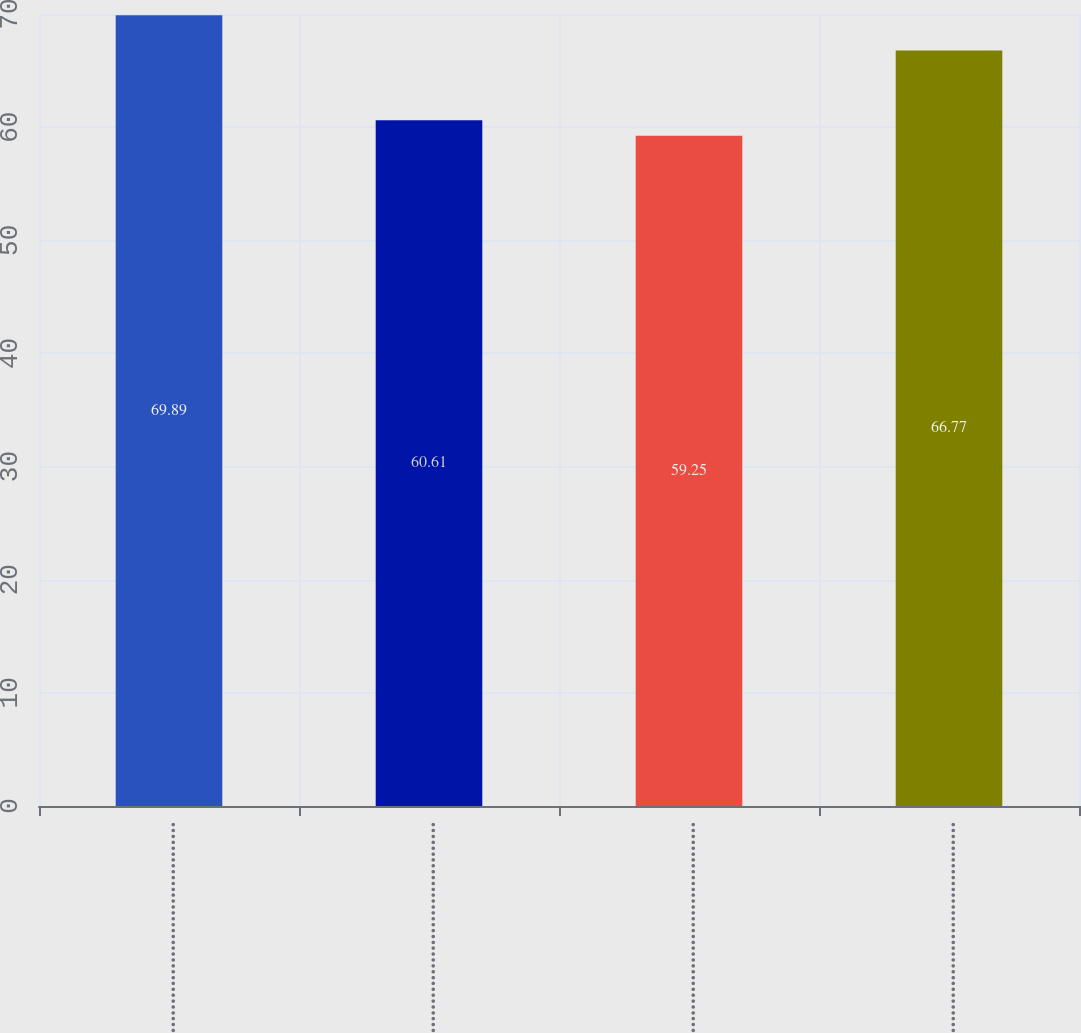<chart> <loc_0><loc_0><loc_500><loc_500><bar_chart><fcel>First………………………………………<fcel>Second……………………………………<fcel>Third………………………………………<fcel>Fourth……………………………………<nl><fcel>69.89<fcel>60.61<fcel>59.25<fcel>66.77<nl></chart> 